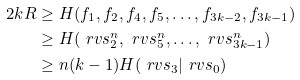Convert formula to latex. <formula><loc_0><loc_0><loc_500><loc_500>2 k R & \geq H ( f _ { 1 } , f _ { 2 } , f _ { 4 } , f _ { 5 } , \dots , f _ { 3 k - 2 } , f _ { 3 k - 1 } ) \\ & \geq H ( \ r v s _ { 2 } ^ { n } , \ r v s _ { 5 } ^ { n } , \dots , \ r v s _ { 3 k - 1 } ^ { n } ) \\ & \geq n ( k - 1 ) H ( \ r v s _ { 3 } | \ r v s _ { 0 } )</formula> 